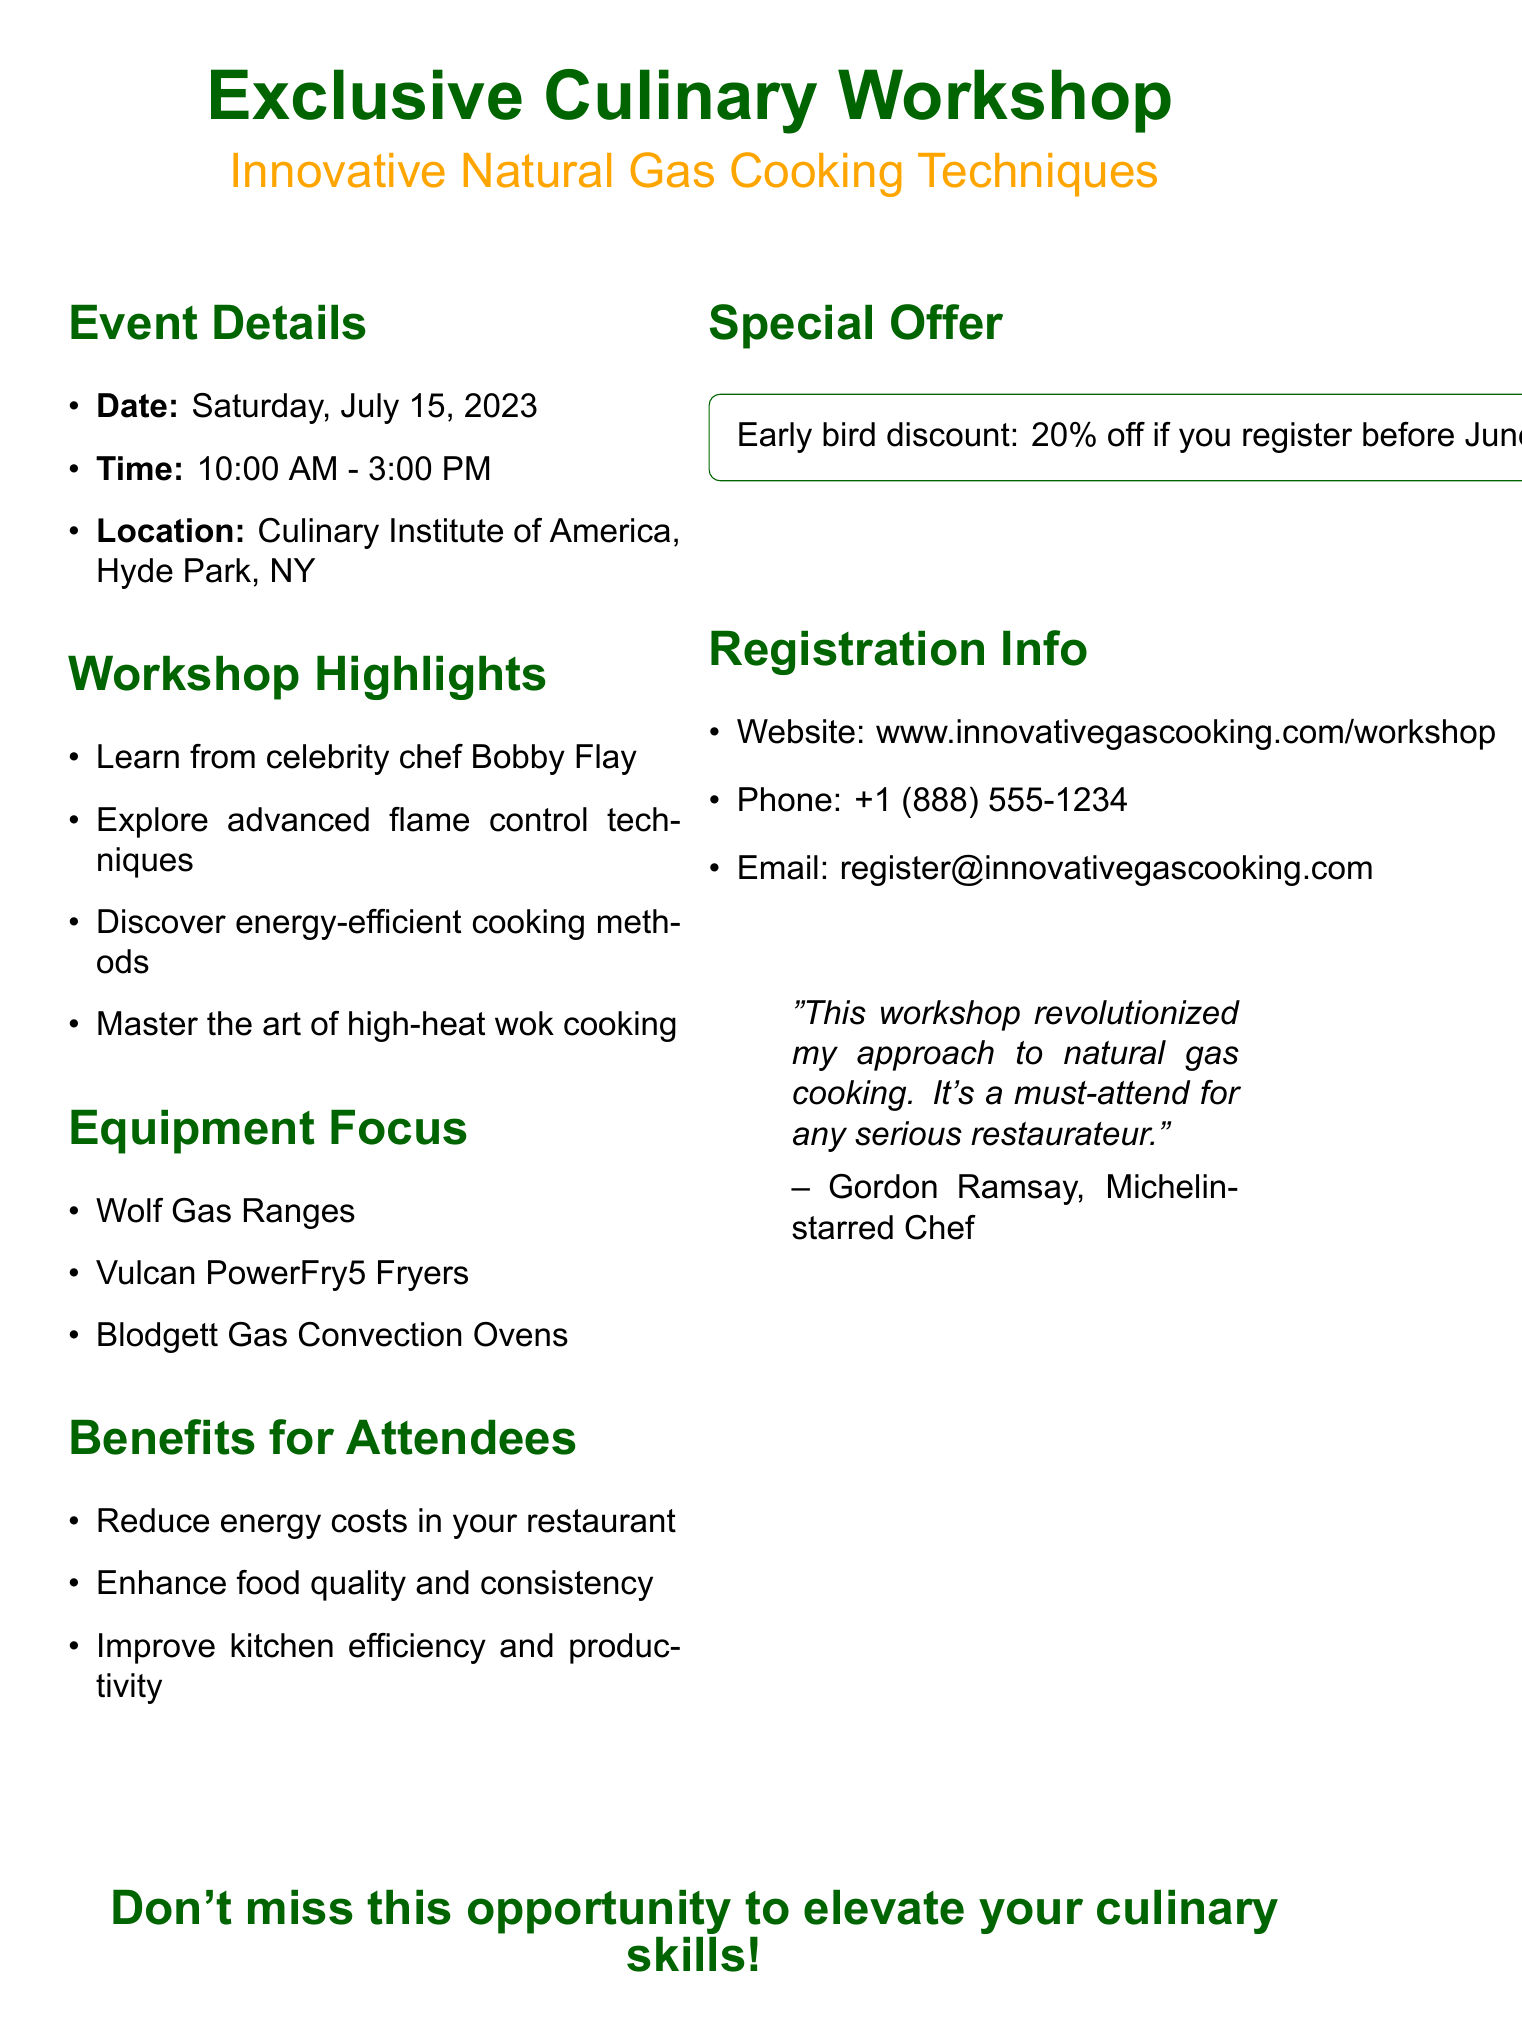what is the date of the workshop? The date of the workshop is explicitly listed in the event details section of the document.
Answer: Saturday, July 15, 2023 what time does the workshop start? The workshop start time is provided in the event details section of the document.
Answer: 10:00 AM who is the celebrity chef leading the workshop? The document mentions the celebrity chef in the workshop highlights section.
Answer: Bobby Flay what is the early bird discount percentage? The percentage of the early bird discount is specified in the special offer section of the document.
Answer: 20% which three types of gas cooking equipment will be focused on? The types of gas cooking equipment are mentioned in the equipment focus section of the document.
Answer: Wolf Gas Ranges, Vulcan PowerFry5 Fryers, Blodgett Gas Convection Ovens how can attendees benefit from the workshop? The benefits are listed in the benefits for attendees section.
Answer: Reduce energy costs, enhance food quality, improve kitchen efficiency why is the workshop considered a must-attend according to the testimonial? The quote from Gordon Ramsay gives a reasoning for why the workshop is essential for restaurateurs.
Answer: Revolutionized my approach to natural gas cooking what location hosts the workshop? The location is included in the event details section of the document.
Answer: Culinary Institute of America, Hyde Park, NY 